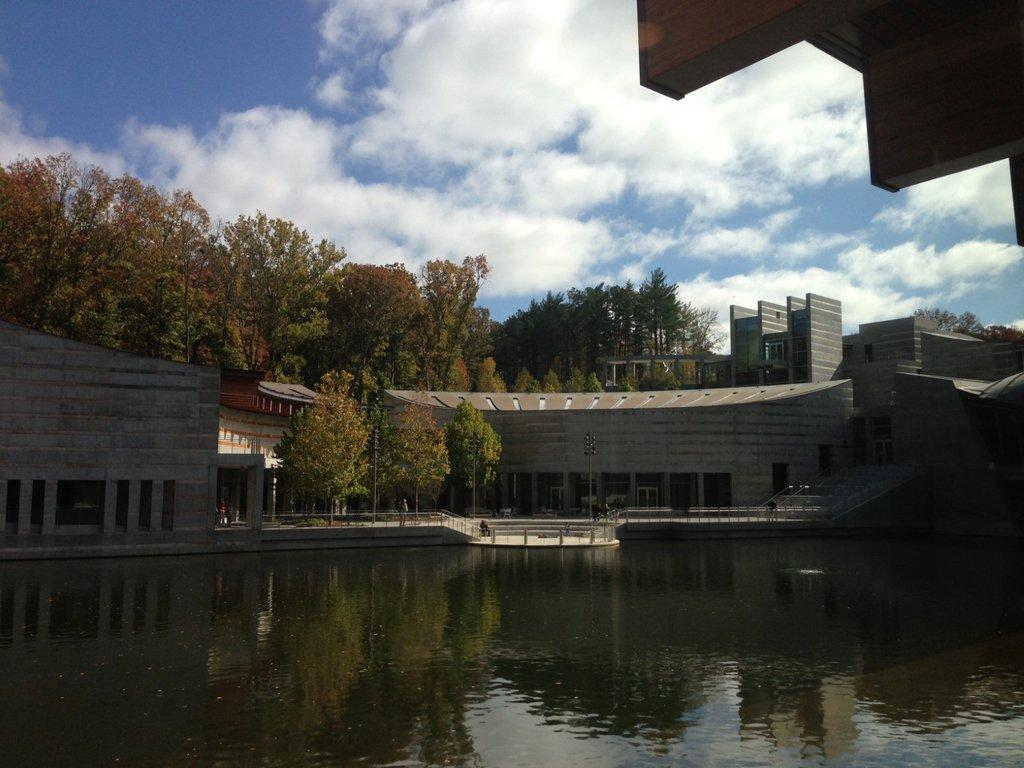What is one of the natural elements visible in the image? Water is visible in the image. What type of structure can be seen in the image? There is a building in the image. What feature of the building is mentioned in the facts? The building has windows. What man-made feature is present in the image? There is a bridge in the image. What type of vegetation is visible in the image? Surrounding trees are present in the image. What can be seen in the sky in the image? Clouds are visible in the sky. What type of bear can be heard making a voice in the image? There are no bears or voices present in the image. What is the source of the flame in the image? There is no flame present in the image. 